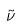<formula> <loc_0><loc_0><loc_500><loc_500>\tilde { \nu }</formula> 